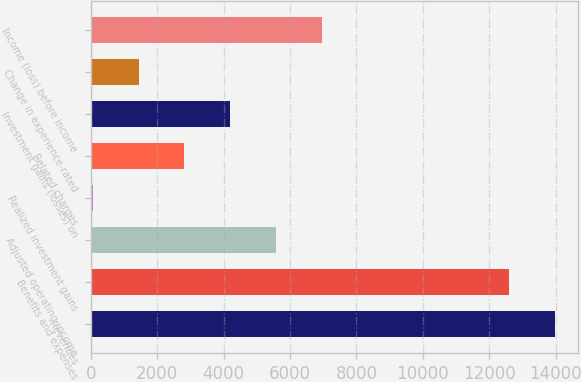Convert chart. <chart><loc_0><loc_0><loc_500><loc_500><bar_chart><fcel>Revenues<fcel>Benefits and expenses<fcel>Adjusted operating income<fcel>Realized investment gains<fcel>Related charges<fcel>Investment gains (losses) on<fcel>Change in experience-rated<fcel>Income (loss) before income<nl><fcel>13977.1<fcel>12599<fcel>5574.4<fcel>62<fcel>2818.2<fcel>4196.3<fcel>1440.1<fcel>6952.5<nl></chart> 